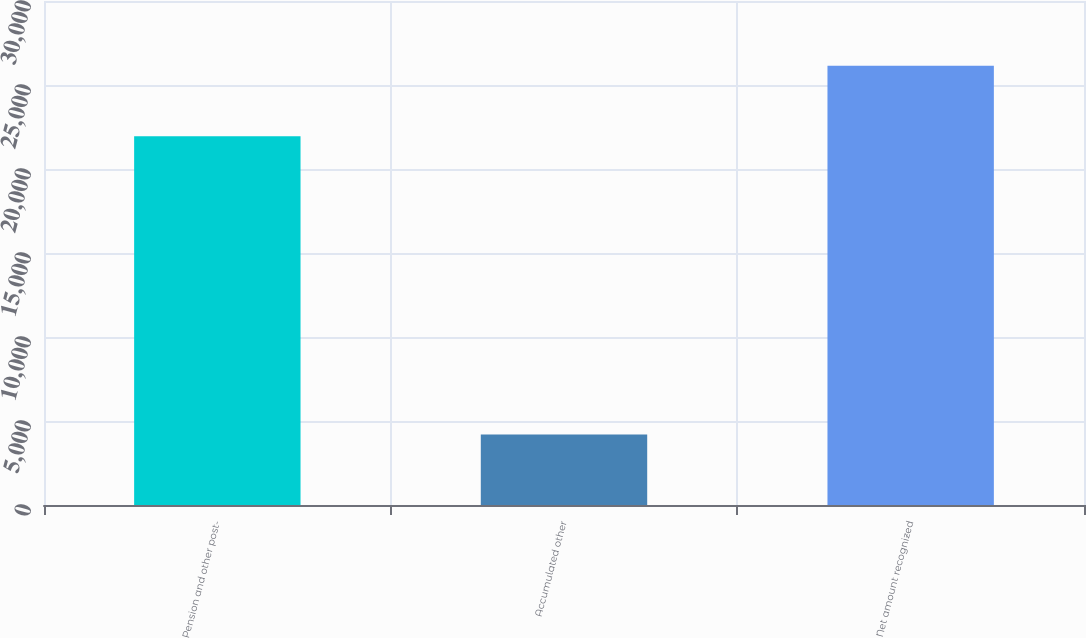Convert chart. <chart><loc_0><loc_0><loc_500><loc_500><bar_chart><fcel>Pension and other post-<fcel>Accumulated other<fcel>Net amount recognized<nl><fcel>21955<fcel>4197<fcel>26152<nl></chart> 